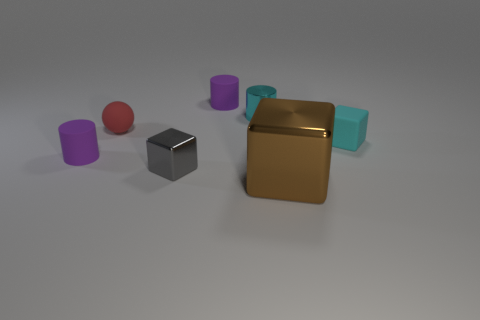There is a tiny cube that is to the right of the small block in front of the matte cylinder in front of the cyan matte block; what is its material?
Offer a very short reply. Rubber. Is the size of the cyan matte object the same as the shiny cylinder?
Your response must be concise. Yes. What is the red sphere made of?
Keep it short and to the point. Rubber. There is a thing that is the same color as the tiny shiny cylinder; what is it made of?
Give a very brief answer. Rubber. Do the matte thing to the right of the large brown shiny cube and the gray shiny thing have the same shape?
Offer a very short reply. Yes. What number of things are cyan matte things or shiny things?
Make the answer very short. 4. Is the purple thing behind the rubber cube made of the same material as the tiny cyan cylinder?
Keep it short and to the point. No. What size is the cyan matte cube?
Make the answer very short. Small. There is a metallic object that is the same color as the tiny rubber cube; what shape is it?
Give a very brief answer. Cylinder. How many balls are either small things or small purple matte things?
Ensure brevity in your answer.  1. 